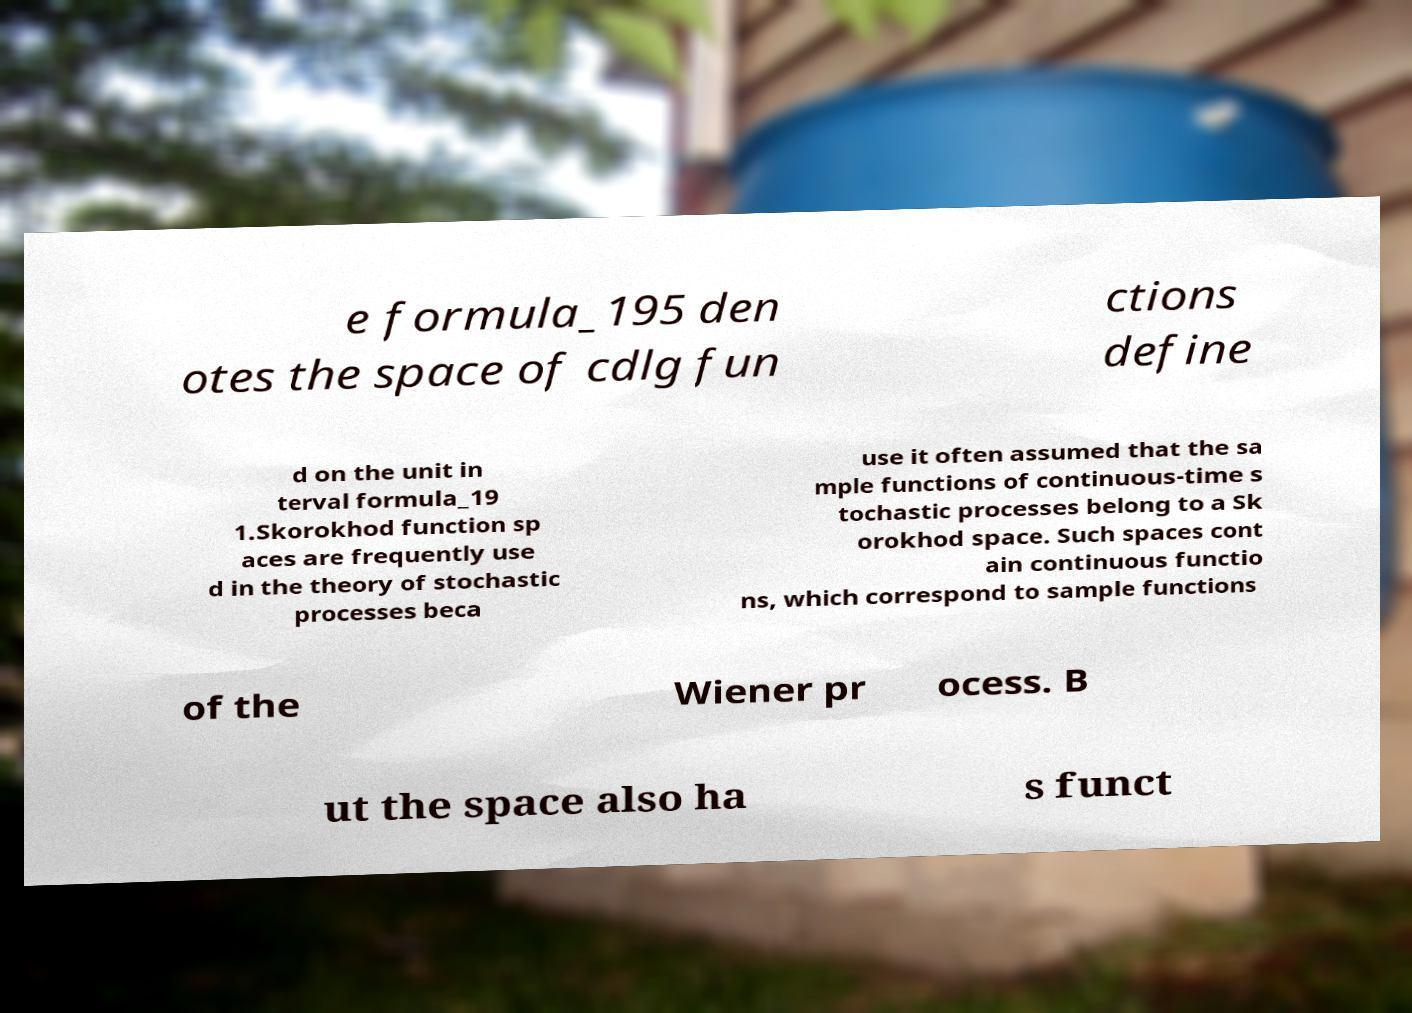For documentation purposes, I need the text within this image transcribed. Could you provide that? e formula_195 den otes the space of cdlg fun ctions define d on the unit in terval formula_19 1.Skorokhod function sp aces are frequently use d in the theory of stochastic processes beca use it often assumed that the sa mple functions of continuous-time s tochastic processes belong to a Sk orokhod space. Such spaces cont ain continuous functio ns, which correspond to sample functions of the Wiener pr ocess. B ut the space also ha s funct 